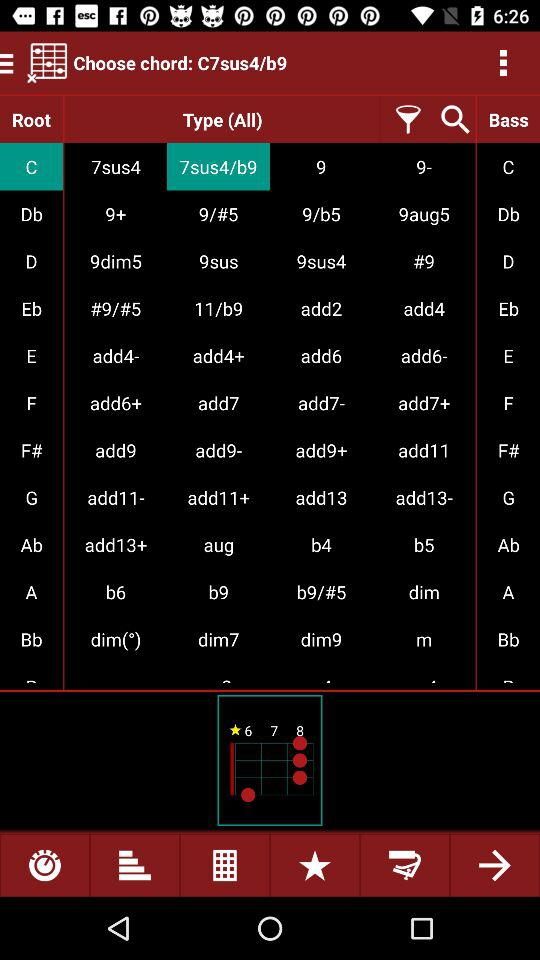Which type is selected for Root C?
When the provided information is insufficient, respond with <no answer>. <no answer> 